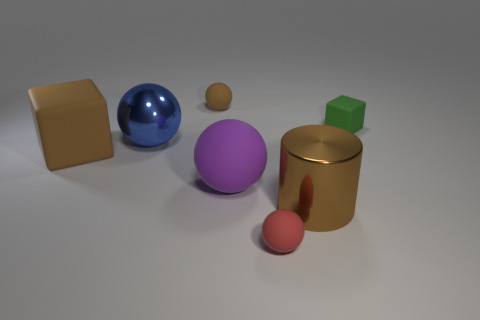Add 2 brown rubber things. How many objects exist? 9 Subtract all cylinders. How many objects are left? 6 Add 3 blue metallic spheres. How many blue metallic spheres exist? 4 Subtract 0 red blocks. How many objects are left? 7 Subtract all big shiny things. Subtract all big brown metal objects. How many objects are left? 4 Add 4 green rubber things. How many green rubber things are left? 5 